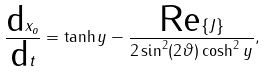<formula> <loc_0><loc_0><loc_500><loc_500>\frac { \text {d} x _ { o } } { \text {d} t } = \tanh { y } - \frac { \text {Re} \{ J \} } { 2 \sin ^ { 2 } ( 2 { \vartheta } ) \cosh ^ { 2 } { y } } ,</formula> 